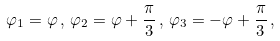<formula> <loc_0><loc_0><loc_500><loc_500>\varphi _ { 1 } = \varphi \, , \, \varphi _ { 2 } = \varphi + \frac { \pi } { 3 } \, , \, \varphi _ { 3 } = - \varphi + \frac { \pi } { 3 } \, , \,</formula> 